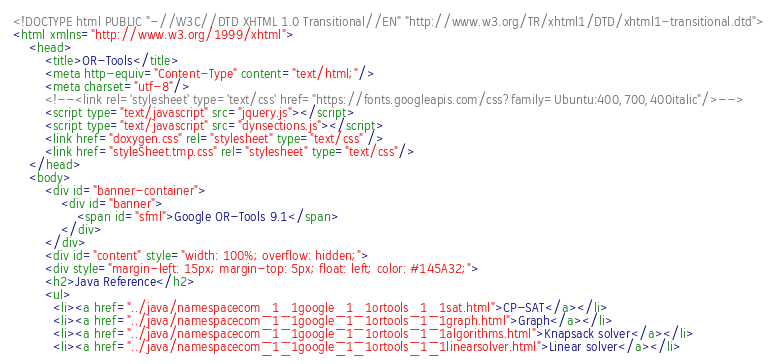<code> <loc_0><loc_0><loc_500><loc_500><_HTML_><!DOCTYPE html PUBLIC "-//W3C//DTD XHTML 1.0 Transitional//EN" "http://www.w3.org/TR/xhtml1/DTD/xhtml1-transitional.dtd">
<html xmlns="http://www.w3.org/1999/xhtml">
    <head>
        <title>OR-Tools</title>
        <meta http-equiv="Content-Type" content="text/html;"/>
        <meta charset="utf-8"/>
        <!--<link rel='stylesheet' type='text/css' href="https://fonts.googleapis.com/css?family=Ubuntu:400,700,400italic"/>-->
        <script type="text/javascript" src="jquery.js"></script>
        <script type="text/javascript" src="dynsections.js"></script>
        <link href="doxygen.css" rel="stylesheet" type="text/css" />
        <link href="styleSheet.tmp.css" rel="stylesheet" type="text/css"/>
    </head>
    <body>
        <div id="banner-container">
            <div id="banner">
                <span id="sfml">Google OR-Tools 9.1</span>
            </div>
        </div>
        <div id="content" style="width: 100%; overflow: hidden;">
        <div style="margin-left: 15px; margin-top: 5px; float: left; color: #145A32;">
        <h2>Java Reference</h2>
        <ul>
          <li><a href="../java/namespacecom_1_1google_1_1ortools_1_1sat.html">CP-SAT</a></li>
          <li><a href="../java/namespacecom_1_1google_1_1ortools_1_1graph.html">Graph</a></li>
          <li><a href="../java/namespacecom_1_1google_1_1ortools_1_1algorithms.html">Knapsack solver</a></li>
          <li><a href="../java/namespacecom_1_1google_1_1ortools_1_1linearsolver.html">Linear solver</a></li></code> 